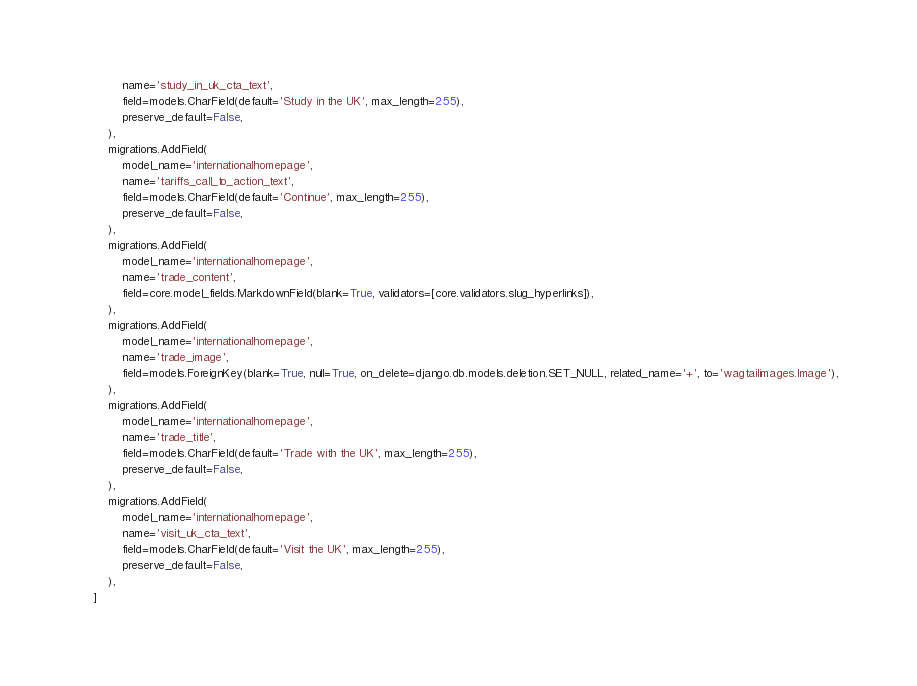<code> <loc_0><loc_0><loc_500><loc_500><_Python_>            name='study_in_uk_cta_text',
            field=models.CharField(default='Study in the UK', max_length=255),
            preserve_default=False,
        ),
        migrations.AddField(
            model_name='internationalhomepage',
            name='tariffs_call_to_action_text',
            field=models.CharField(default='Continue', max_length=255),
            preserve_default=False,
        ),
        migrations.AddField(
            model_name='internationalhomepage',
            name='trade_content',
            field=core.model_fields.MarkdownField(blank=True, validators=[core.validators.slug_hyperlinks]),
        ),
        migrations.AddField(
            model_name='internationalhomepage',
            name='trade_image',
            field=models.ForeignKey(blank=True, null=True, on_delete=django.db.models.deletion.SET_NULL, related_name='+', to='wagtailimages.Image'),
        ),
        migrations.AddField(
            model_name='internationalhomepage',
            name='trade_title',
            field=models.CharField(default='Trade with the UK', max_length=255),
            preserve_default=False,
        ),
        migrations.AddField(
            model_name='internationalhomepage',
            name='visit_uk_cta_text',
            field=models.CharField(default='Visit the UK', max_length=255),
            preserve_default=False,
        ),
    ]
</code> 